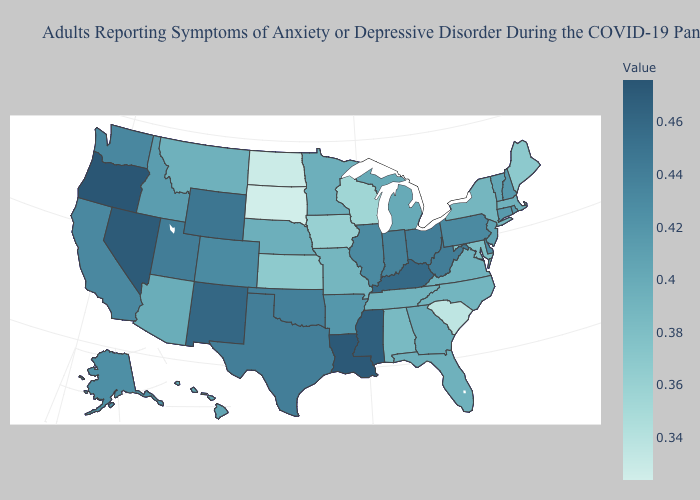Which states hav the highest value in the Northeast?
Be succinct. Pennsylvania. Does New York have the highest value in the Northeast?
Give a very brief answer. No. Does Minnesota have a higher value than Nevada?
Keep it brief. No. Does Oregon have the highest value in the USA?
Short answer required. Yes. Among the states that border North Dakota , does South Dakota have the lowest value?
Write a very short answer. Yes. Does Kentucky have a higher value than Idaho?
Keep it brief. Yes. Which states have the lowest value in the South?
Answer briefly. South Carolina. 